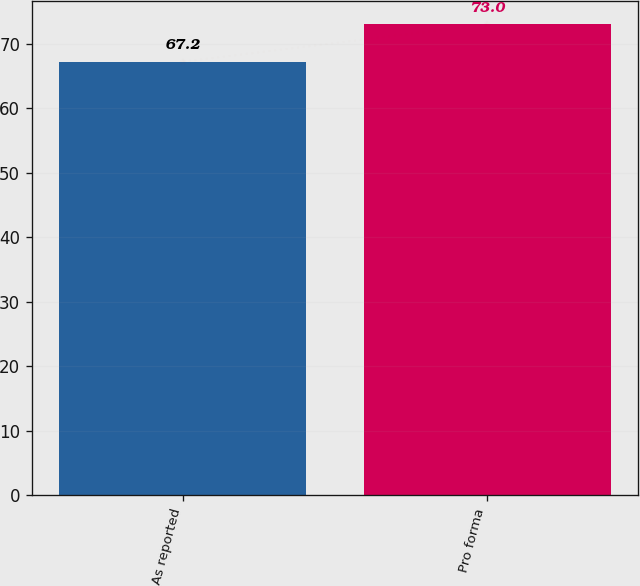Convert chart to OTSL. <chart><loc_0><loc_0><loc_500><loc_500><bar_chart><fcel>As reported<fcel>Pro forma<nl><fcel>67.2<fcel>73<nl></chart> 